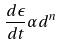Convert formula to latex. <formula><loc_0><loc_0><loc_500><loc_500>\frac { d \epsilon } { d t } \alpha d ^ { n }</formula> 